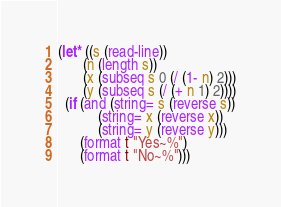Convert code to text. <code><loc_0><loc_0><loc_500><loc_500><_Lisp_>(let* ((s (read-line))
       (n (length s))
       (x (subseq s 0 (/ (1- n) 2)))
       (y (subseq s (/ (+ n 1) 2))))
  (if (and (string= s (reverse s))
           (string= x (reverse x))
           (string= y (reverse y)))
      (format t "Yes~%")
      (format t "No~%")))
</code> 